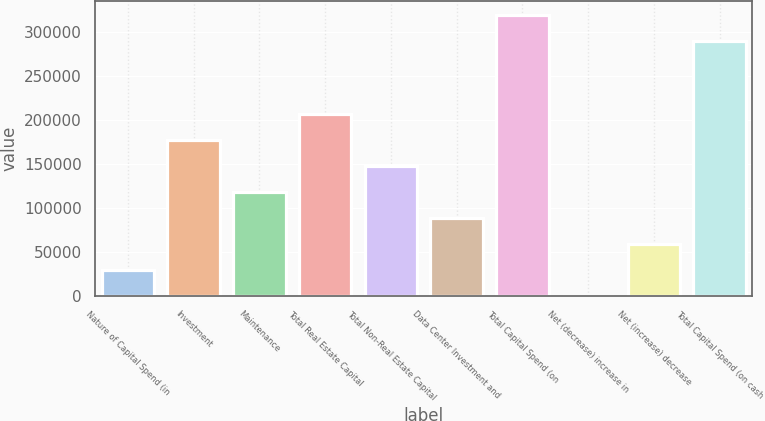<chart> <loc_0><loc_0><loc_500><loc_500><bar_chart><fcel>Nature of Capital Spend (in<fcel>Investment<fcel>Maintenance<fcel>Total Real Estate Capital<fcel>Total Non-Real Estate Capital<fcel>Data Center Investment and<fcel>Total Capital Spend (on<fcel>Net (decrease) increase in<fcel>Net (increase) decrease<fcel>Total Capital Spend (on cash<nl><fcel>29818.6<fcel>177102<fcel>118188<fcel>206558<fcel>147645<fcel>88731.8<fcel>319706<fcel>362<fcel>59275.2<fcel>290249<nl></chart> 